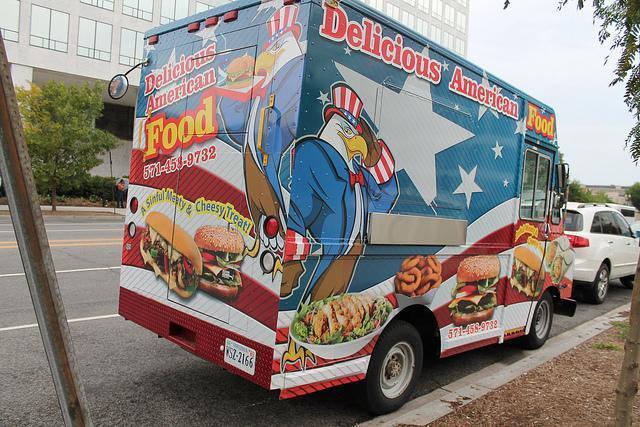How many items does the man hold?
Give a very brief answer. 0. 